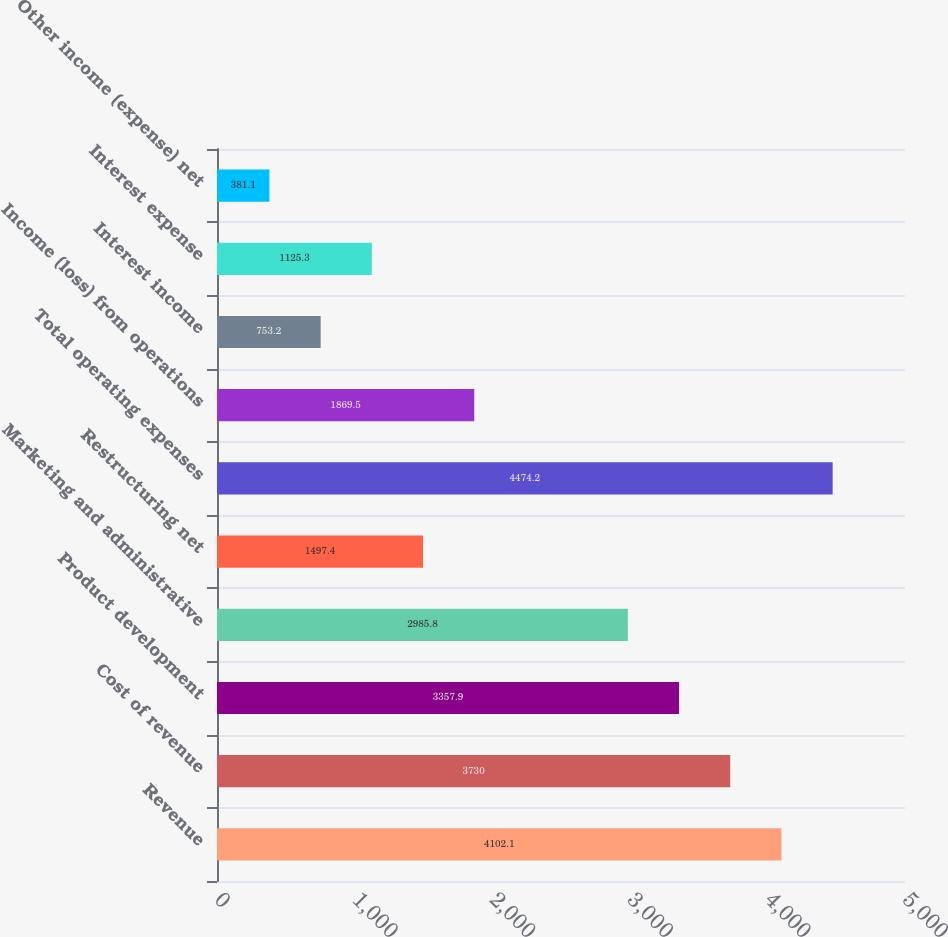<chart> <loc_0><loc_0><loc_500><loc_500><bar_chart><fcel>Revenue<fcel>Cost of revenue<fcel>Product development<fcel>Marketing and administrative<fcel>Restructuring net<fcel>Total operating expenses<fcel>Income (loss) from operations<fcel>Interest income<fcel>Interest expense<fcel>Other income (expense) net<nl><fcel>4102.1<fcel>3730<fcel>3357.9<fcel>2985.8<fcel>1497.4<fcel>4474.2<fcel>1869.5<fcel>753.2<fcel>1125.3<fcel>381.1<nl></chart> 